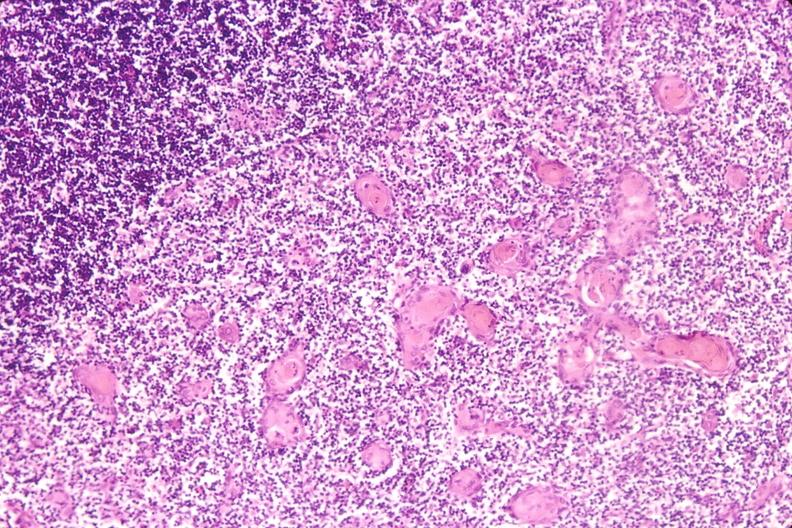what induce involution in baby with hyaline membrane disease?
Answer the question using a single word or phrase. Stress 